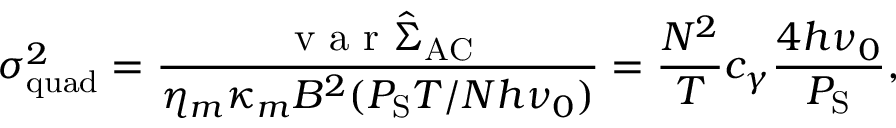Convert formula to latex. <formula><loc_0><loc_0><loc_500><loc_500>\sigma _ { q u a d } ^ { 2 } = \frac { v a r \hat { \Sigma } _ { A C } } { \eta _ { m } \kappa _ { m } B ^ { 2 } ( P _ { S } T / N h \nu _ { 0 } ) } = \frac { N ^ { 2 } } { T } c _ { \gamma } \frac { 4 h \nu _ { 0 } } { P _ { S } } ,</formula> 